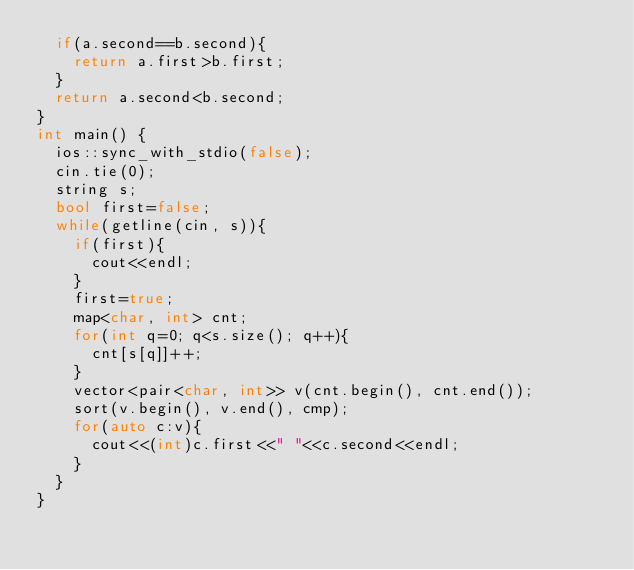Convert code to text. <code><loc_0><loc_0><loc_500><loc_500><_C++_>	if(a.second==b.second){
		return a.first>b.first;
	}
	return a.second<b.second;
}
int main() {
	ios::sync_with_stdio(false);
	cin.tie(0);
	string s;
	bool first=false;
	while(getline(cin, s)){
		if(first){
			cout<<endl;
		}
		first=true;
		map<char, int> cnt;
		for(int q=0; q<s.size(); q++){
			cnt[s[q]]++;
		}
		vector<pair<char, int>> v(cnt.begin(), cnt.end());
		sort(v.begin(), v.end(), cmp);
		for(auto c:v){
			cout<<(int)c.first<<" "<<c.second<<endl;
		}
	}
}
</code> 